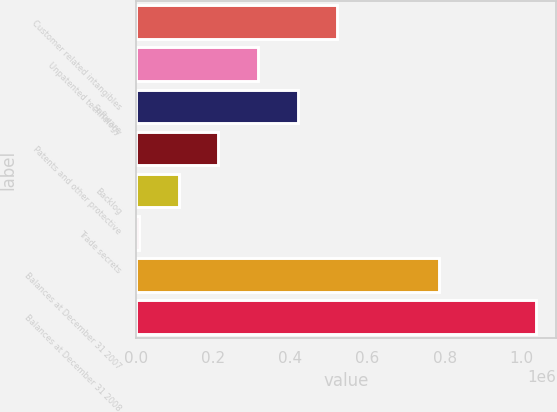Convert chart to OTSL. <chart><loc_0><loc_0><loc_500><loc_500><bar_chart><fcel>Customer related intangibles<fcel>Unpatented technology<fcel>Software<fcel>Patents and other protective<fcel>Backlog<fcel>Trade secrets<fcel>Balances at December 31 2007<fcel>Balances at December 31 2008<nl><fcel>522052<fcel>316003<fcel>419027<fcel>212979<fcel>109954<fcel>6930<fcel>785461<fcel>1.03717e+06<nl></chart> 